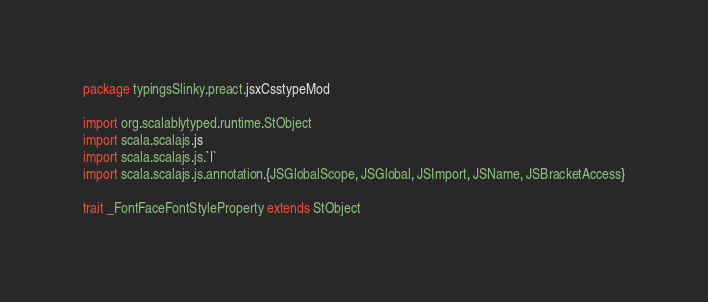<code> <loc_0><loc_0><loc_500><loc_500><_Scala_>package typingsSlinky.preact.jsxCsstypeMod

import org.scalablytyped.runtime.StObject
import scala.scalajs.js
import scala.scalajs.js.`|`
import scala.scalajs.js.annotation.{JSGlobalScope, JSGlobal, JSImport, JSName, JSBracketAccess}

trait _FontFaceFontStyleProperty extends StObject
</code> 